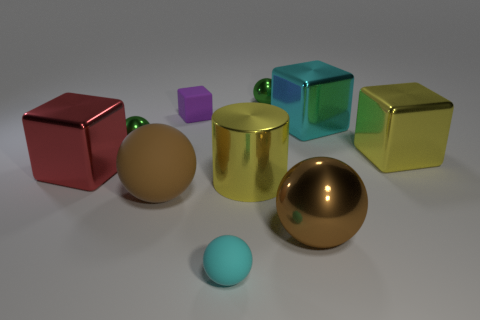How does the lighting in this image affect the appearance of the objects? The lighting in the image creates a soft, diffused effect that highlights the glossy textures and metallic reflections of the objects. Shadows are softened, which contributes to the overall calm and balanced composition of the scene. 